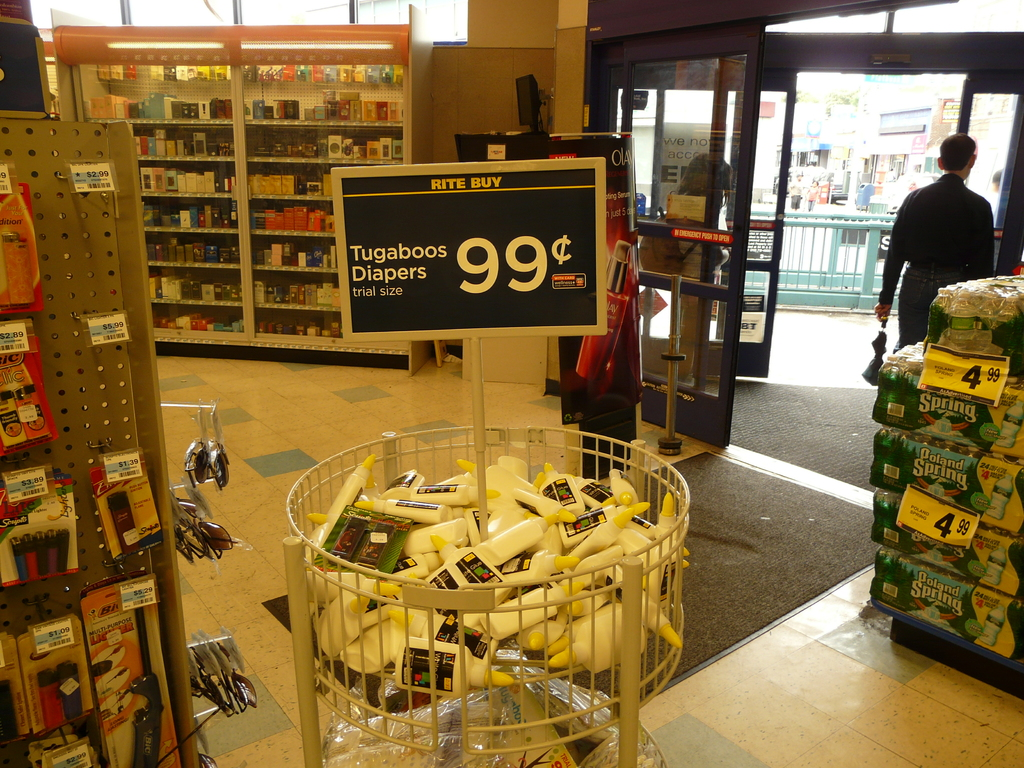Provide a one-sentence caption for the provided image. A special offer on trial-sized Tugaboos Diapers placed in a prominent display at the entrance of a retail store with a price tag of $4.99, positioned to attract customers as they walk in. 